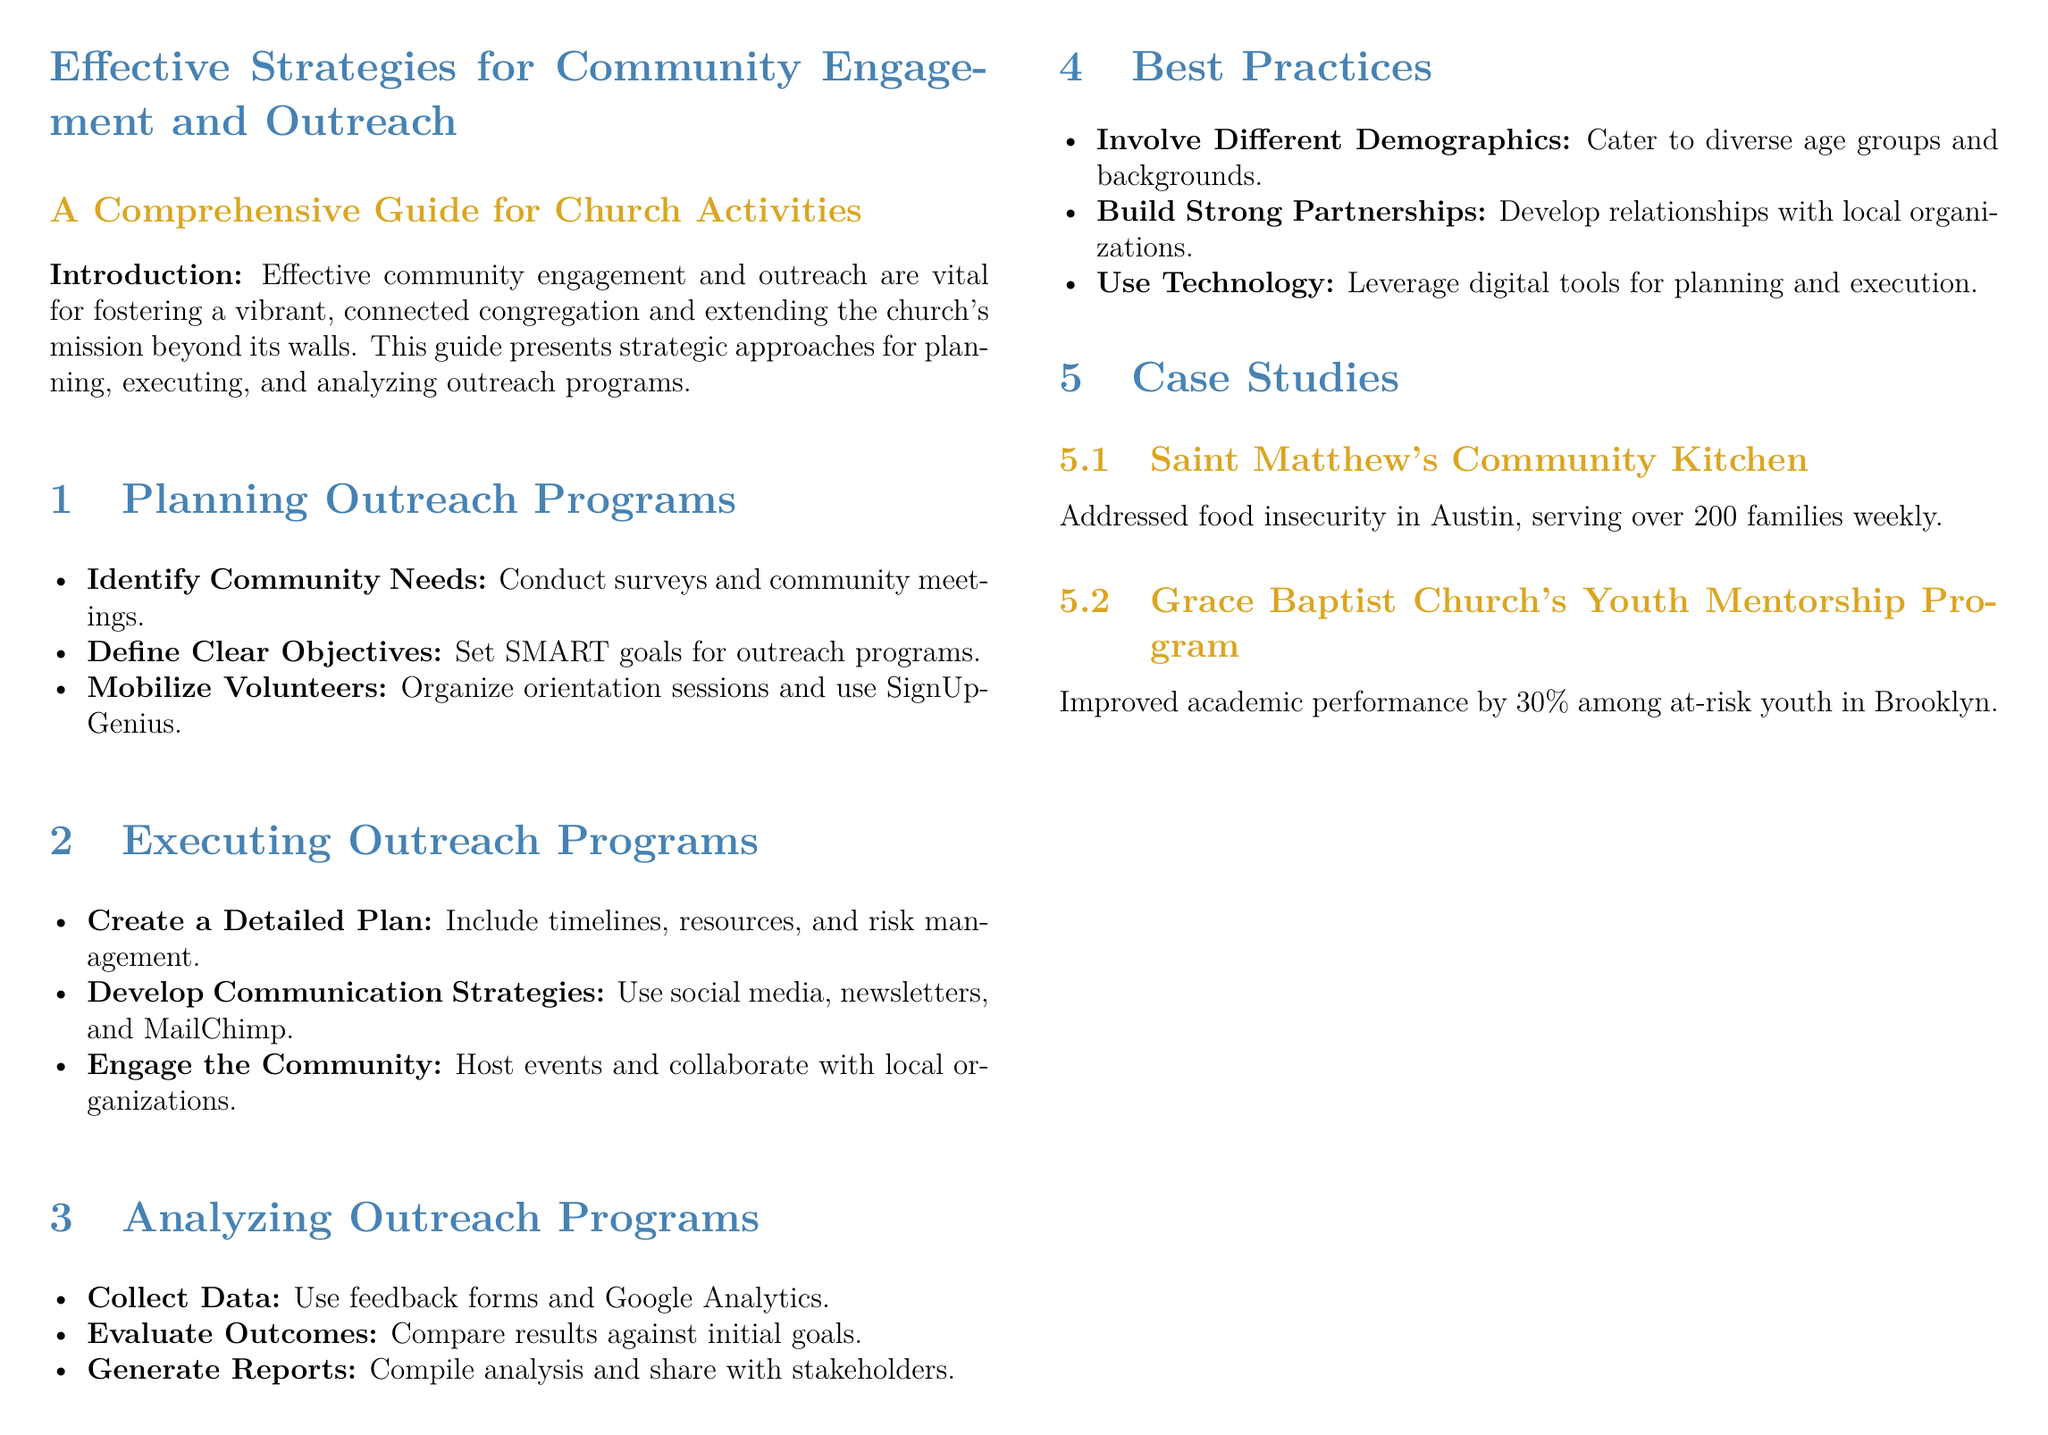What is the primary focus of the guide? The guide focuses on strategies for effective community engagement and outreach in church activities.
Answer: community engagement and outreach What is one method suggested for identifying community needs? The document suggests conducting surveys and community meetings as a method for identifying community needs.
Answer: surveys and community meetings What does SMART stand for in goal setting? The document does not explicitly define SMART, but it is widely understood to refer to Specific, Measurable, Achievable, Relevant, and Time-bound goals.
Answer: Specific, Measurable, Achievable, Relevant, Time-bound How often did Saint Matthew's Community Kitchen serve families? The document states that Saint Matthew's Community Kitchen served over 200 families weekly.
Answer: weekly What is one best practice for outreach programs mentioned in the document? The document highlights the involvement of different demographics as a best practice for outreach programs.
Answer: Involve different demographics What tool is recommended for mobilizing volunteers? SignUpGenius is recommended for organizing volunteer mobilization.
Answer: SignUpGenius What is the percentage improvement achieved by Grace Baptist Church's Youth Mentorship Program? The program improved academic performance by 30% among at-risk youth.
Answer: 30% What is the main type of analysis suggested for outreach programs? The document suggests evaluating outcomes by comparing results against initial goals as a main type of analysis.
Answer: Evaluate outcomes Which digital tool is mentioned for communication strategies? MailChimp is mentioned as a digital tool for communication strategies in outreach programs.
Answer: MailChimp 